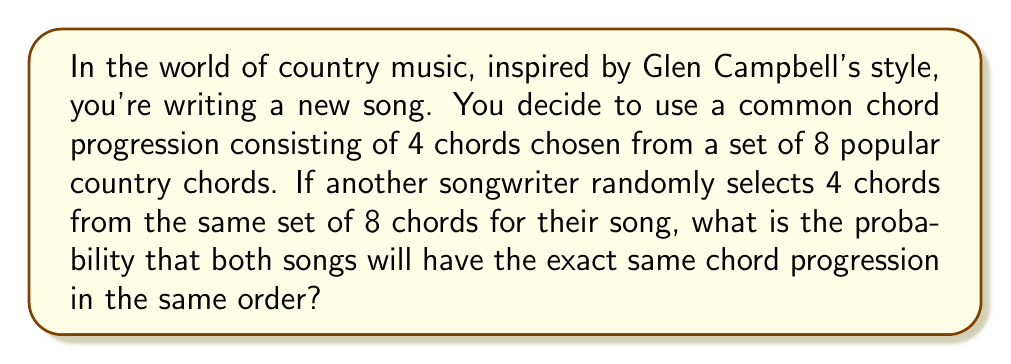Provide a solution to this math problem. Let's approach this step-by-step:

1) First, we need to calculate the total number of possible 4-chord progressions from 8 chords. This is a permutation with repetition allowed, as chords can be repeated in a progression.

   Total possible progressions = $8^4 = 4096$

2) For the two songs to have the exact same chord progression in the same order, all 4 chord positions must match. The probability of this happening is the same as the probability of choosing one specific progression out of all possible progressions.

3) The probability of choosing any specific progression is:

   $P(\text{specific progression}) = \frac{1}{\text{total possible progressions}} = \frac{1}{4096}$

4) Therefore, the probability that both songwriters choose the exact same chord progression in the same order is $\frac{1}{4096}$.

5) We can also express this as a percentage:

   $\frac{1}{4096} \times 100\% \approx 0.0244\%$

This very low probability explains why it's rare to find two songs with exactly the same chord progression, even within the same genre like country music inspired by Glen Campbell.
Answer: The probability is $\frac{1}{4096}$ or approximately $0.0244\%$. 